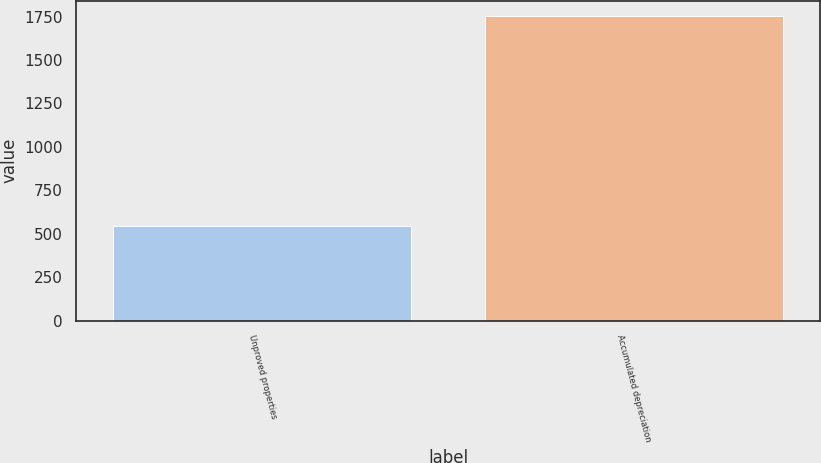Convert chart to OTSL. <chart><loc_0><loc_0><loc_500><loc_500><bar_chart><fcel>Unproved properties<fcel>Accumulated depreciation<nl><fcel>542<fcel>1754<nl></chart> 